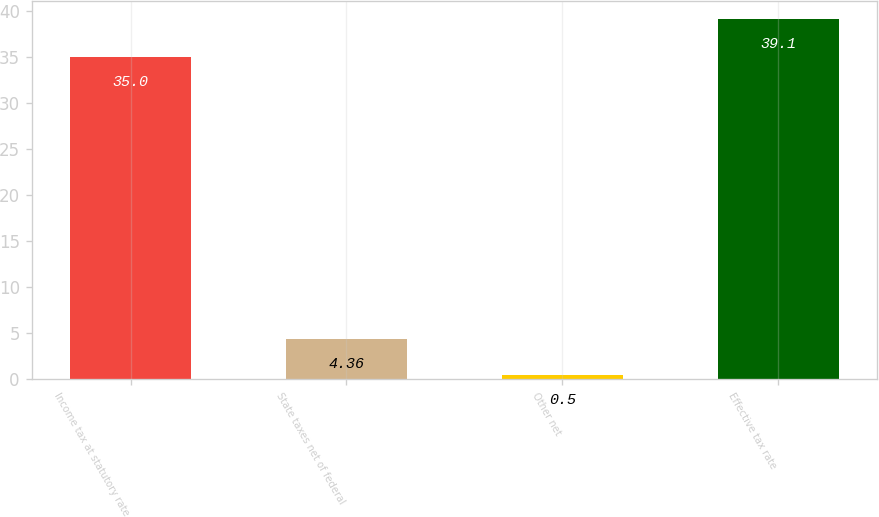<chart> <loc_0><loc_0><loc_500><loc_500><bar_chart><fcel>Income tax at statutory rate<fcel>State taxes net of federal<fcel>Other net<fcel>Effective tax rate<nl><fcel>35<fcel>4.36<fcel>0.5<fcel>39.1<nl></chart> 